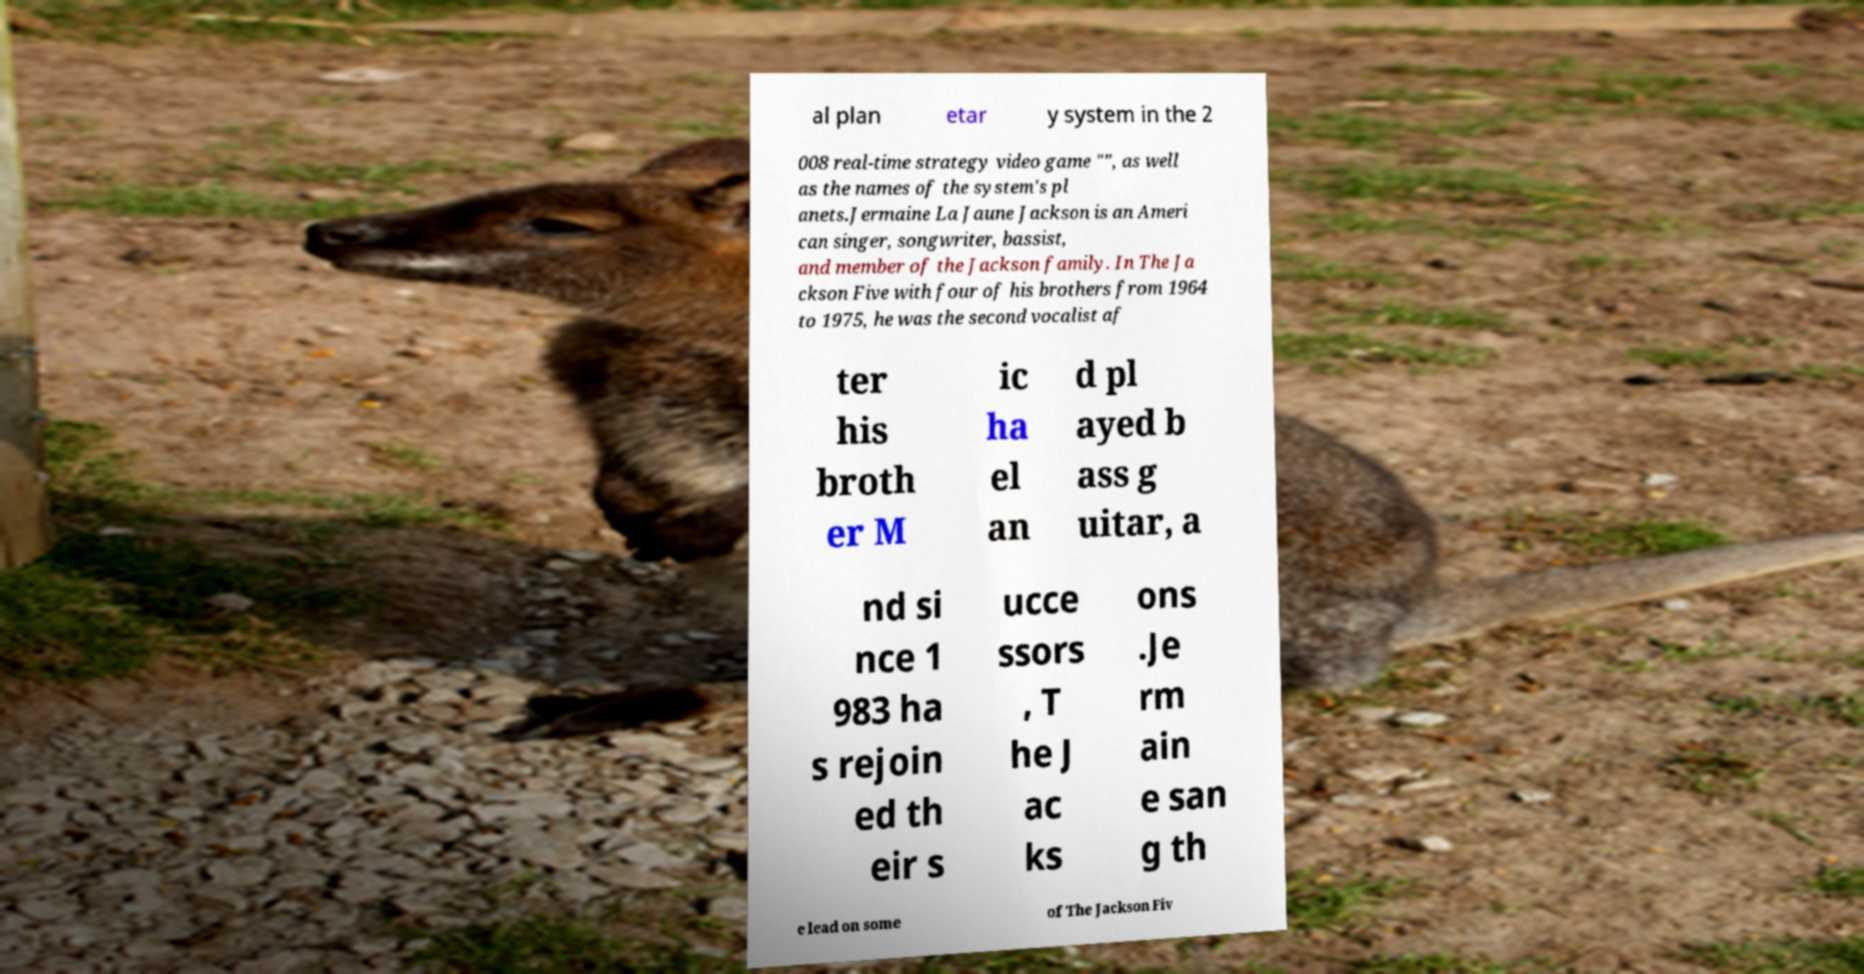Could you extract and type out the text from this image? al plan etar y system in the 2 008 real-time strategy video game "", as well as the names of the system's pl anets.Jermaine La Jaune Jackson is an Ameri can singer, songwriter, bassist, and member of the Jackson family. In The Ja ckson Five with four of his brothers from 1964 to 1975, he was the second vocalist af ter his broth er M ic ha el an d pl ayed b ass g uitar, a nd si nce 1 983 ha s rejoin ed th eir s ucce ssors , T he J ac ks ons .Je rm ain e san g th e lead on some of The Jackson Fiv 